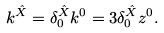<formula> <loc_0><loc_0><loc_500><loc_500>k ^ { \hat { X } } = \delta ^ { \hat { X } } _ { 0 } k ^ { 0 } = 3 \delta ^ { \hat { X } } _ { 0 } z ^ { 0 } .</formula> 